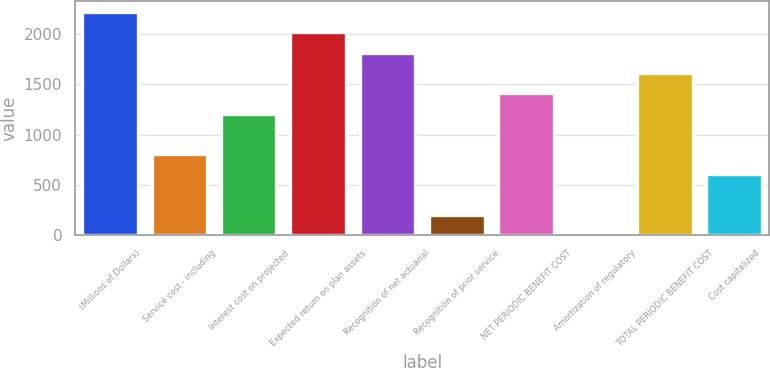Convert chart. <chart><loc_0><loc_0><loc_500><loc_500><bar_chart><fcel>(Millions of Dollars)<fcel>Service cost - including<fcel>Interest cost on projected<fcel>Expected return on plan assets<fcel>Recognition of net actuarial<fcel>Recognition of prior service<fcel>NET PERIODIC BENEFIT COST<fcel>Amortization of regulatory<fcel>TOTAL PERIODIC BENEFIT COST<fcel>Cost capitalized<nl><fcel>2215.2<fcel>806.8<fcel>1209.2<fcel>2014<fcel>1812.8<fcel>203.2<fcel>1410.4<fcel>2<fcel>1611.6<fcel>605.6<nl></chart> 